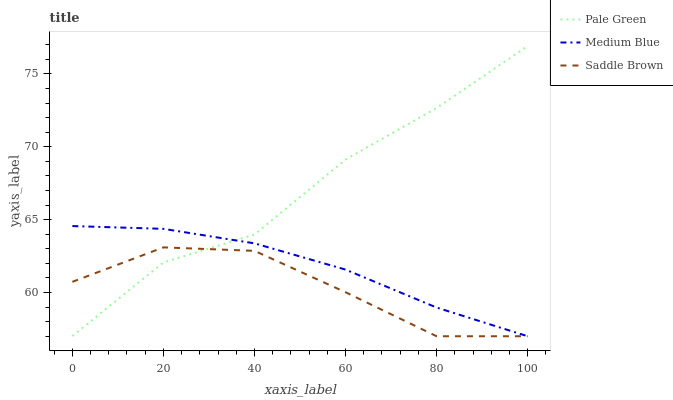Does Saddle Brown have the minimum area under the curve?
Answer yes or no. Yes. Does Pale Green have the maximum area under the curve?
Answer yes or no. Yes. Does Medium Blue have the minimum area under the curve?
Answer yes or no. No. Does Medium Blue have the maximum area under the curve?
Answer yes or no. No. Is Medium Blue the smoothest?
Answer yes or no. Yes. Is Pale Green the roughest?
Answer yes or no. Yes. Is Saddle Brown the smoothest?
Answer yes or no. No. Is Saddle Brown the roughest?
Answer yes or no. No. Does Pale Green have the highest value?
Answer yes or no. Yes. Does Medium Blue have the highest value?
Answer yes or no. No. Does Medium Blue intersect Pale Green?
Answer yes or no. Yes. Is Medium Blue less than Pale Green?
Answer yes or no. No. Is Medium Blue greater than Pale Green?
Answer yes or no. No. 